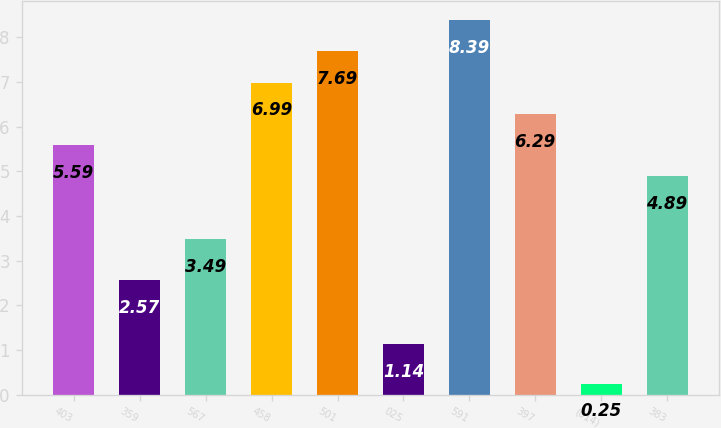Convert chart to OTSL. <chart><loc_0><loc_0><loc_500><loc_500><bar_chart><fcel>403<fcel>359<fcel>567<fcel>458<fcel>501<fcel>025<fcel>591<fcel>397<fcel>(014)<fcel>383<nl><fcel>5.59<fcel>2.57<fcel>3.49<fcel>6.99<fcel>7.69<fcel>1.14<fcel>8.39<fcel>6.29<fcel>0.25<fcel>4.89<nl></chart> 